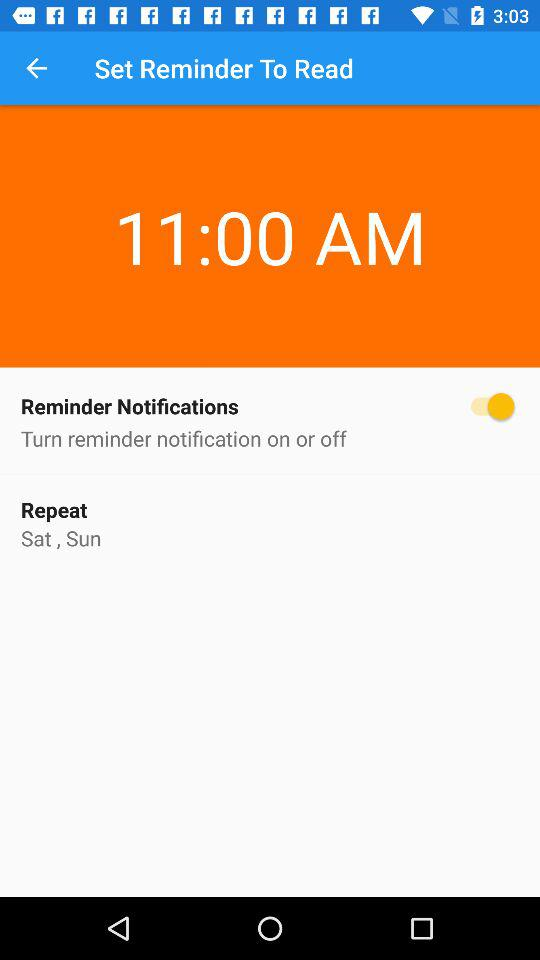What is the time of the reminder?
Answer the question using a single word or phrase. 11:00 AM 